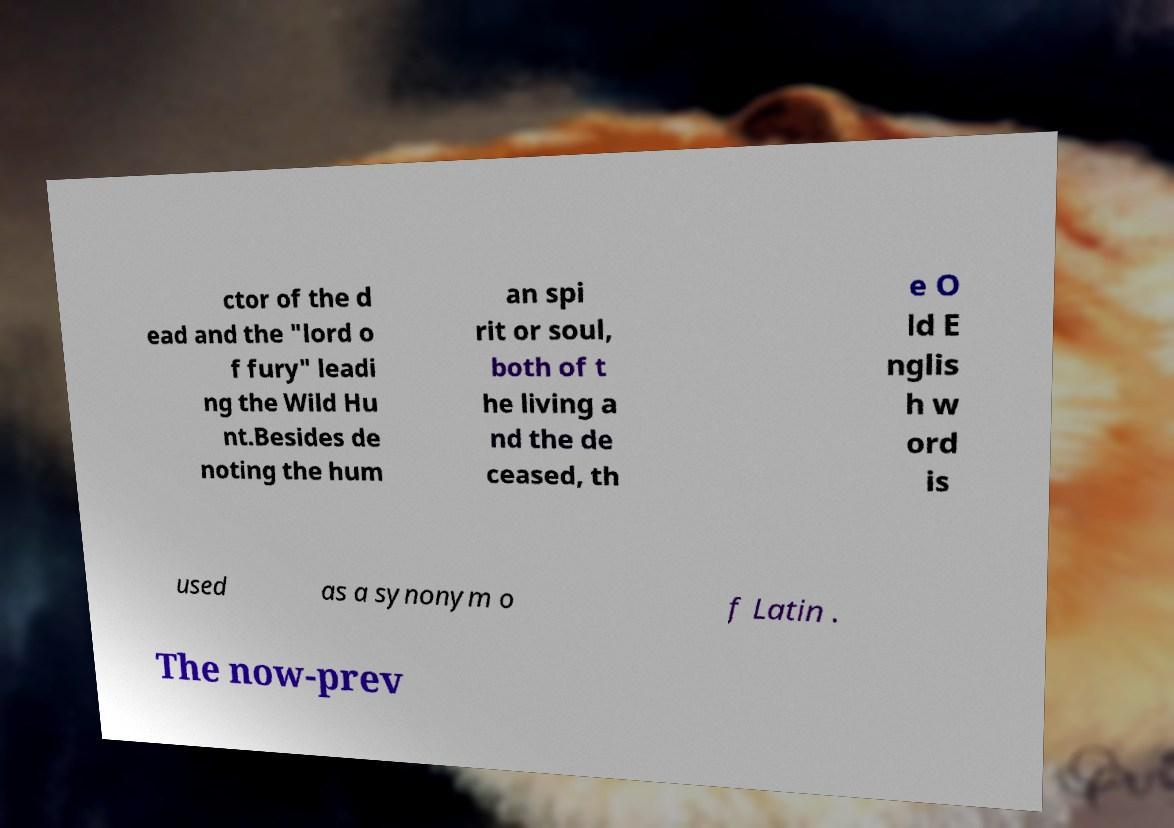Could you assist in decoding the text presented in this image and type it out clearly? ctor of the d ead and the "lord o f fury" leadi ng the Wild Hu nt.Besides de noting the hum an spi rit or soul, both of t he living a nd the de ceased, th e O ld E nglis h w ord is used as a synonym o f Latin . The now-prev 